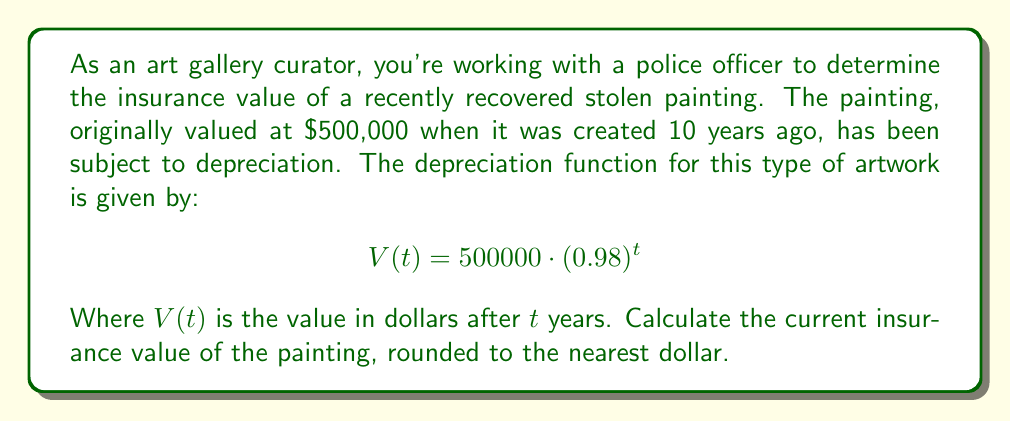Can you solve this math problem? To solve this problem, we need to use the given depreciation function and plug in the appropriate value for $t$.

1. The depreciation function is:
   $$V(t) = 500000 \cdot (0.98)^t$$

2. We know that the painting was created 10 years ago, so $t = 10$.

3. Let's substitute $t = 10$ into the function:
   $$V(10) = 500000 \cdot (0.98)^{10}$$

4. Now we can calculate this value:
   $$V(10) = 500000 \cdot 0.8171461884$$
   $$V(10) = 408573.0942$$

5. Rounding to the nearest dollar:
   $$V(10) \approx 408573$$

Therefore, the current insurance value of the painting is $408,573.
Answer: $408,573 